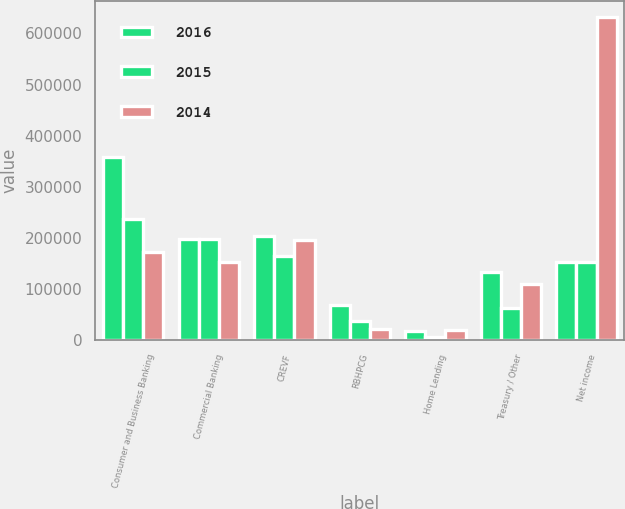<chart> <loc_0><loc_0><loc_500><loc_500><stacked_bar_chart><ecel><fcel>Consumer and Business Banking<fcel>Commercial Banking<fcel>CREVF<fcel>RBHPCG<fcel>Home Lending<fcel>Treasury / Other<fcel>Net income<nl><fcel>2016<fcel>358146<fcel>197375<fcel>203029<fcel>68504<fcel>17837<fcel>133070<fcel>152653<nl><fcel>2015<fcel>236298<fcel>198008<fcel>164830<fcel>37861<fcel>6561<fcel>62521<fcel>152653<nl><fcel>2014<fcel>172199<fcel>152653<fcel>196377<fcel>22010<fcel>19727<fcel>108880<fcel>632392<nl></chart> 